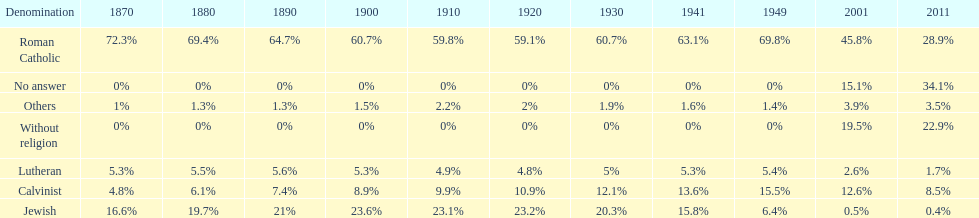Parse the full table. {'header': ['Denomination', '1870', '1880', '1890', '1900', '1910', '1920', '1930', '1941', '1949', '2001', '2011'], 'rows': [['Roman Catholic', '72.3%', '69.4%', '64.7%', '60.7%', '59.8%', '59.1%', '60.7%', '63.1%', '69.8%', '45.8%', '28.9%'], ['No answer', '0%', '0%', '0%', '0%', '0%', '0%', '0%', '0%', '0%', '15.1%', '34.1%'], ['Others', '1%', '1.3%', '1.3%', '1.5%', '2.2%', '2%', '1.9%', '1.6%', '1.4%', '3.9%', '3.5%'], ['Without religion', '0%', '0%', '0%', '0%', '0%', '0%', '0%', '0%', '0%', '19.5%', '22.9%'], ['Lutheran', '5.3%', '5.5%', '5.6%', '5.3%', '4.9%', '4.8%', '5%', '5.3%', '5.4%', '2.6%', '1.7%'], ['Calvinist', '4.8%', '6.1%', '7.4%', '8.9%', '9.9%', '10.9%', '12.1%', '13.6%', '15.5%', '12.6%', '8.5%'], ['Jewish', '16.6%', '19.7%', '21%', '23.6%', '23.1%', '23.2%', '20.3%', '15.8%', '6.4%', '0.5%', '0.4%']]} Which denomination percentage increased the most after 1949? Without religion. 